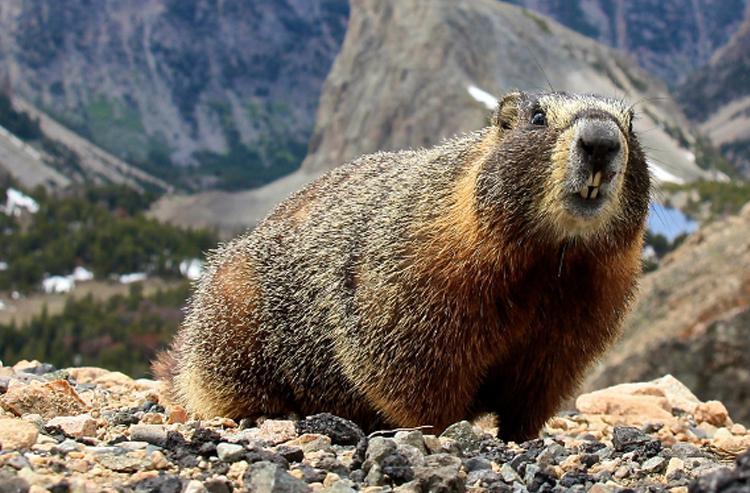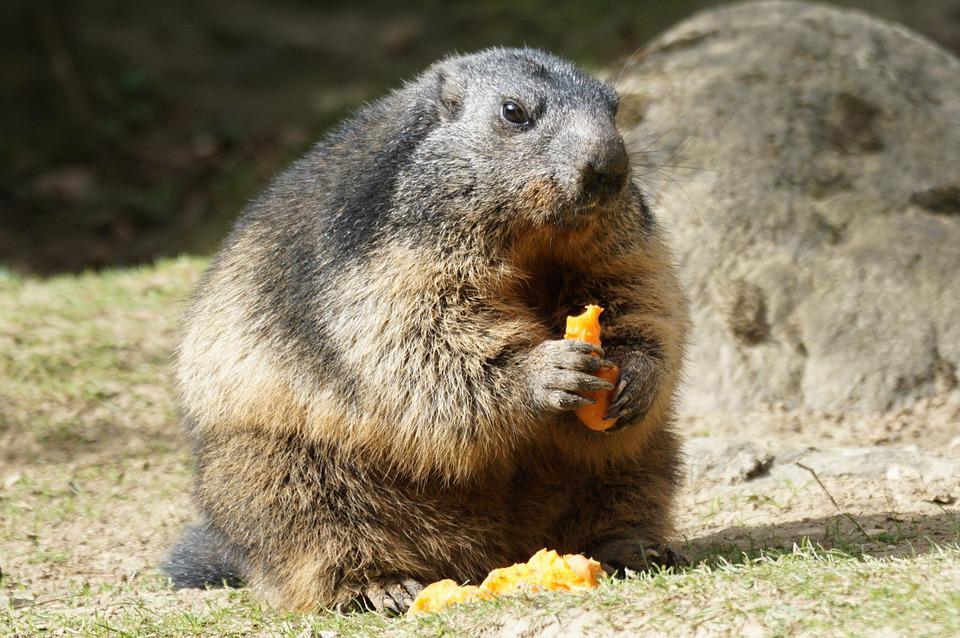The first image is the image on the left, the second image is the image on the right. Examine the images to the left and right. Is the description "The animal in the image on the right is holding orange food." accurate? Answer yes or no. Yes. 